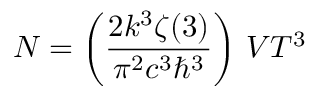Convert formula to latex. <formula><loc_0><loc_0><loc_500><loc_500>N = \left ( { \frac { 2 k ^ { 3 } \zeta ( 3 ) } { \pi ^ { 2 } c ^ { 3 } \hbar { ^ } { 3 } } } \right ) \, V T ^ { 3 }</formula> 